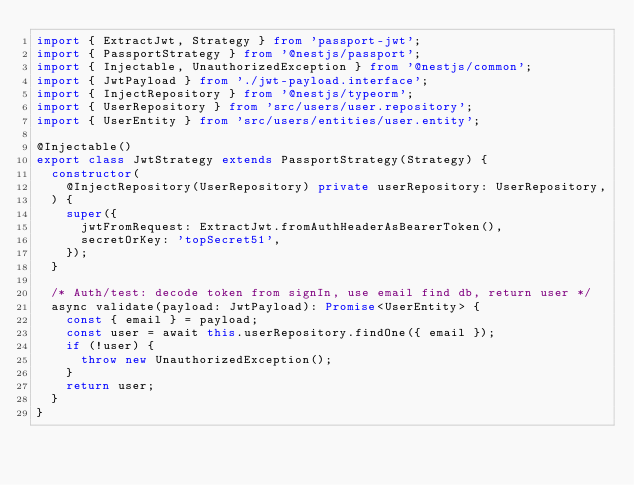<code> <loc_0><loc_0><loc_500><loc_500><_TypeScript_>import { ExtractJwt, Strategy } from 'passport-jwt';
import { PassportStrategy } from '@nestjs/passport';
import { Injectable, UnauthorizedException } from '@nestjs/common';
import { JwtPayload } from './jwt-payload.interface';
import { InjectRepository } from '@nestjs/typeorm';
import { UserRepository } from 'src/users/user.repository';
import { UserEntity } from 'src/users/entities/user.entity';

@Injectable()
export class JwtStrategy extends PassportStrategy(Strategy) {
  constructor(
    @InjectRepository(UserRepository) private userRepository: UserRepository,
  ) {
    super({
      jwtFromRequest: ExtractJwt.fromAuthHeaderAsBearerToken(),
      secretOrKey: 'topSecret51',
    });
  }

  /* Auth/test: decode token from signIn, use email find db, return user */
  async validate(payload: JwtPayload): Promise<UserEntity> {
    const { email } = payload;
    const user = await this.userRepository.findOne({ email });
    if (!user) {
      throw new UnauthorizedException();
    }
    return user;
  }
}
</code> 